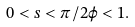<formula> <loc_0><loc_0><loc_500><loc_500>0 < s < \pi / 2 \varphi < 1 .</formula> 